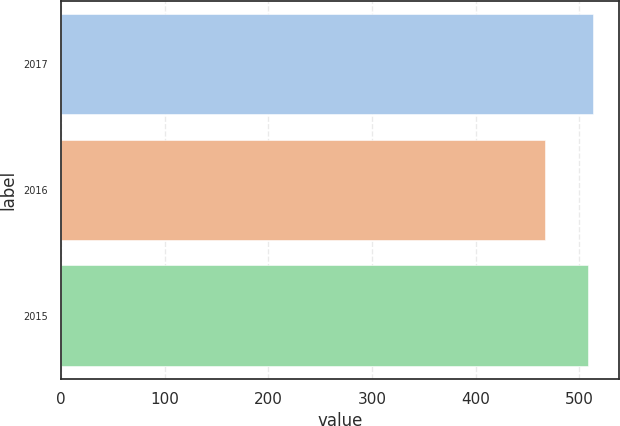<chart> <loc_0><loc_0><loc_500><loc_500><bar_chart><fcel>2017<fcel>2016<fcel>2015<nl><fcel>512.78<fcel>467.4<fcel>508.5<nl></chart> 